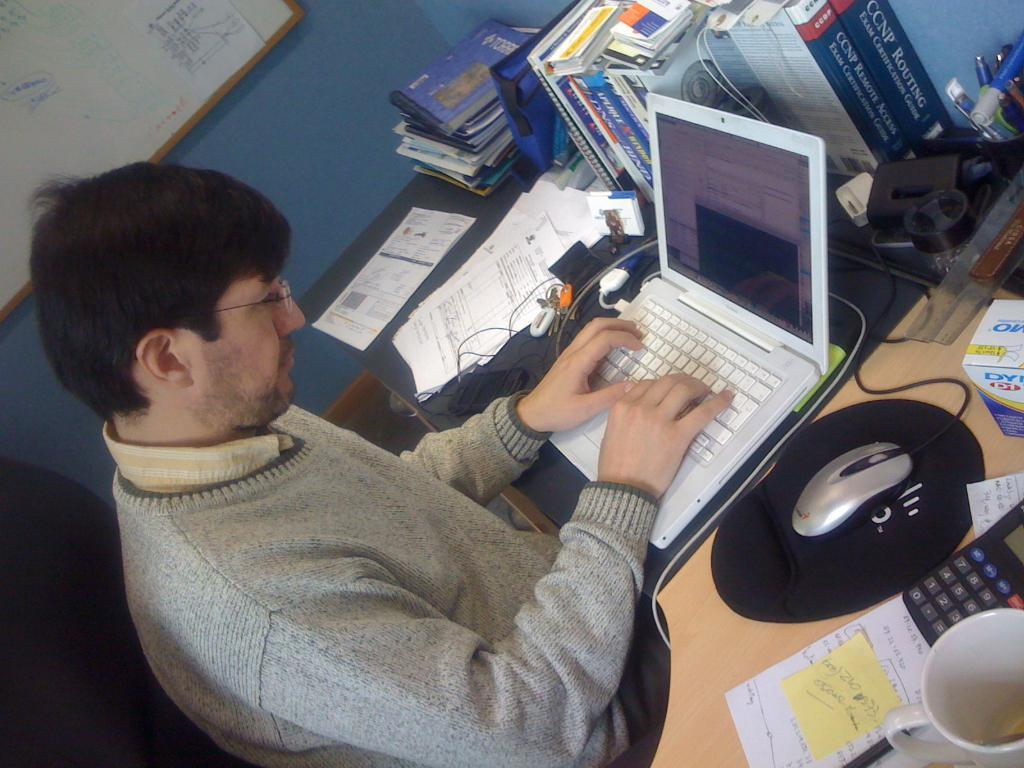Who is the person in the image? There is a man in the image. What is the man doing in the image? The man is using a laptop. What accessory is the man wearing in the image? The man is wearing glasses (specs) in the image. What else can be seen on the table in the image? There are items on the table in the image. What type of plastic is covering the man's stomach in the image? There is no plastic covering the man's stomach in the image. How many light bulbs are visible in the image? There are no light bulbs visible in the image. 